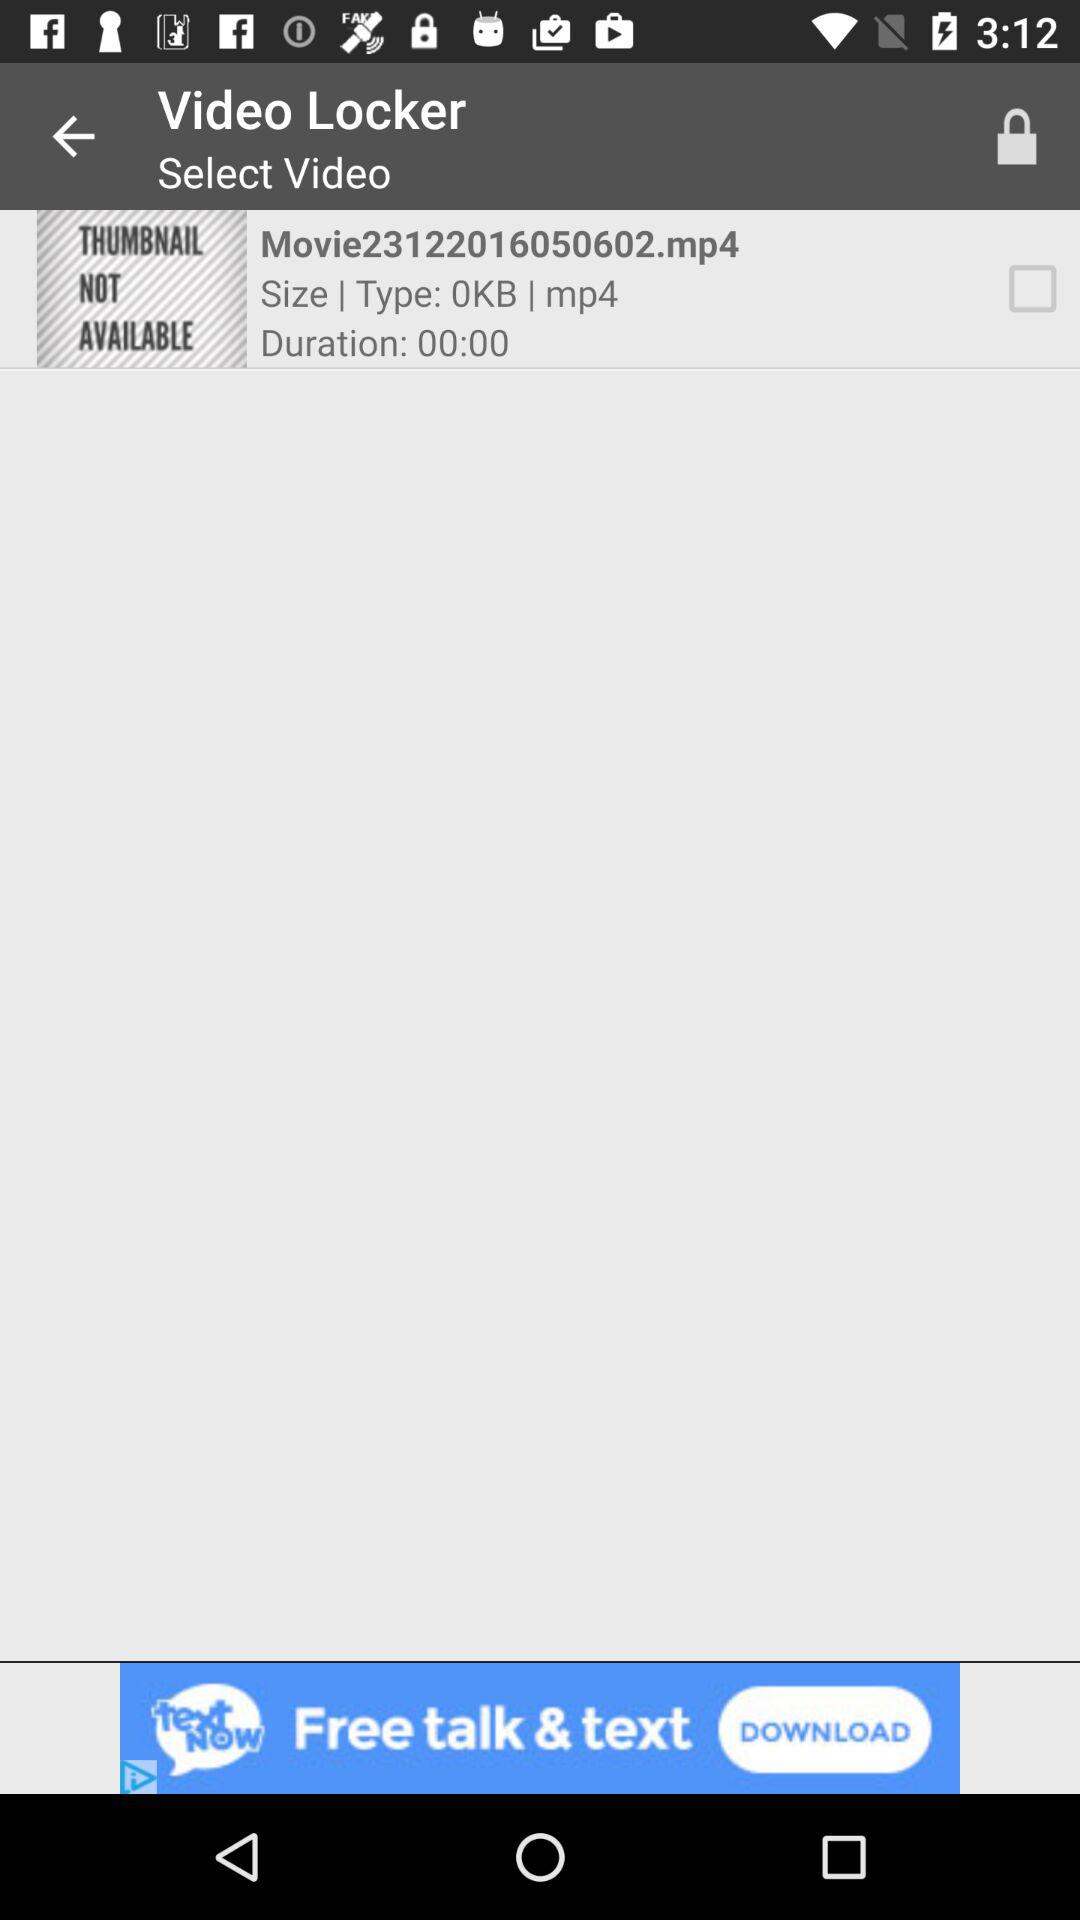What is the status of the video? The status is off. 